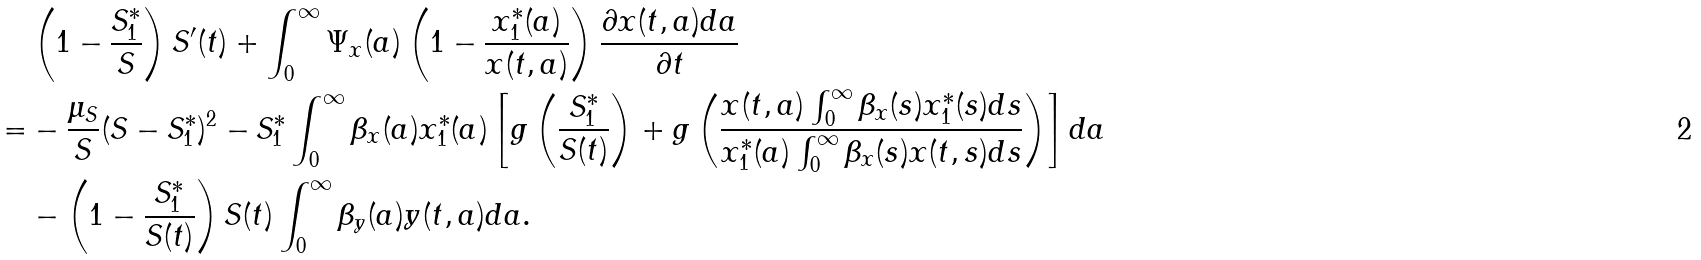Convert formula to latex. <formula><loc_0><loc_0><loc_500><loc_500>& \left ( 1 - \frac { S ^ { * } _ { 1 } } { S } \right ) S ^ { \prime } ( t ) + \int _ { 0 } ^ { \infty } \Psi _ { x } ( a ) \left ( 1 - \frac { x ^ { * } _ { 1 } ( a ) } { x ( t , a ) } \right ) \frac { \partial x ( t , a ) d a } { \partial t } \\ = & - \frac { \mu _ { S } } { S } ( S - S ^ { * } _ { 1 } ) ^ { 2 } - S ^ { * } _ { 1 } \int _ { 0 } ^ { \infty } \beta _ { x } ( a ) x ^ { * } _ { 1 } ( a ) \left [ g \left ( \frac { S ^ { * } _ { 1 } } { S ( t ) } \right ) + g \left ( \frac { x ( t , a ) \int _ { 0 } ^ { \infty } \beta _ { x } ( s ) x ^ { * } _ { 1 } ( s ) d s } { x ^ { * } _ { 1 } ( a ) \int _ { 0 } ^ { \infty } \beta _ { x } ( s ) x ( t , s ) d s } \right ) \right ] d a \\ & - \left ( 1 - \frac { S ^ { * } _ { 1 } } { S ( t ) } \right ) S ( t ) \int _ { 0 } ^ { \infty } \beta _ { y } ( a ) y ( t , a ) d a .</formula> 